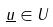Convert formula to latex. <formula><loc_0><loc_0><loc_500><loc_500>\underline { u } \in U</formula> 